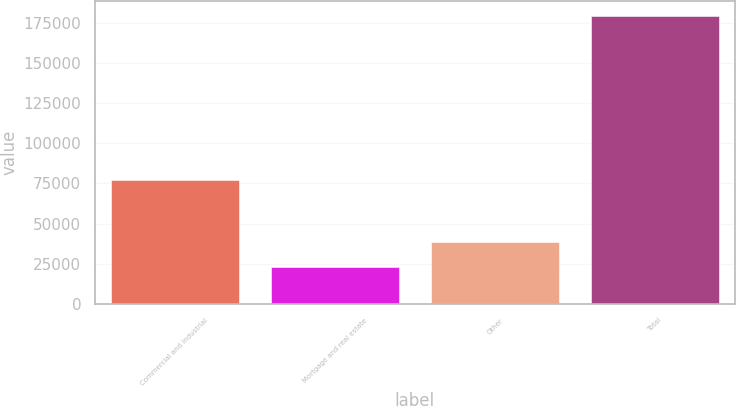<chart> <loc_0><loc_0><loc_500><loc_500><bar_chart><fcel>Commercial and industrial<fcel>Mortgage and real estate<fcel>Other<fcel>Total<nl><fcel>76862<fcel>22892<fcel>38526.1<fcel>179233<nl></chart> 